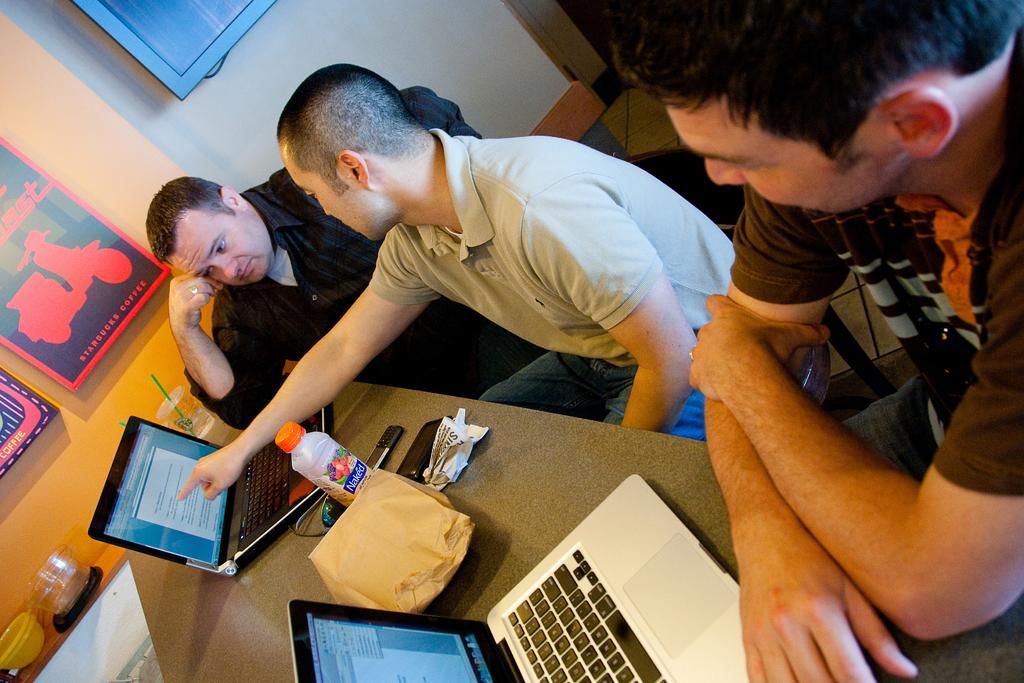Describe this image in one or two sentences. In this picture we can see three men, in front of them we can find laptops, bottle, mobiles and other things on the countertop, on the left side of the image we can see few posters on the wall. 